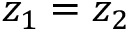<formula> <loc_0><loc_0><loc_500><loc_500>z _ { 1 } = z _ { 2 }</formula> 